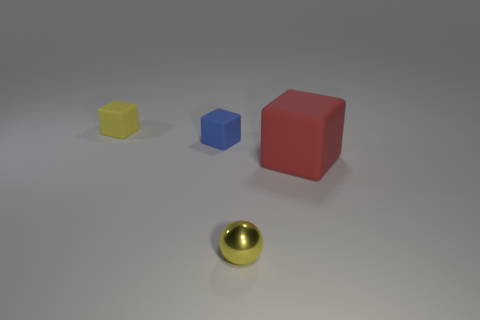Add 1 cyan things. How many objects exist? 5 Subtract all blue cubes. How many cubes are left? 2 Subtract all tiny cubes. How many cubes are left? 1 Subtract all green cubes. How many purple balls are left? 0 Subtract all yellow objects. Subtract all large red matte things. How many objects are left? 1 Add 4 big matte blocks. How many big matte blocks are left? 5 Add 3 big blocks. How many big blocks exist? 4 Subtract 0 red cylinders. How many objects are left? 4 Subtract all balls. How many objects are left? 3 Subtract 3 cubes. How many cubes are left? 0 